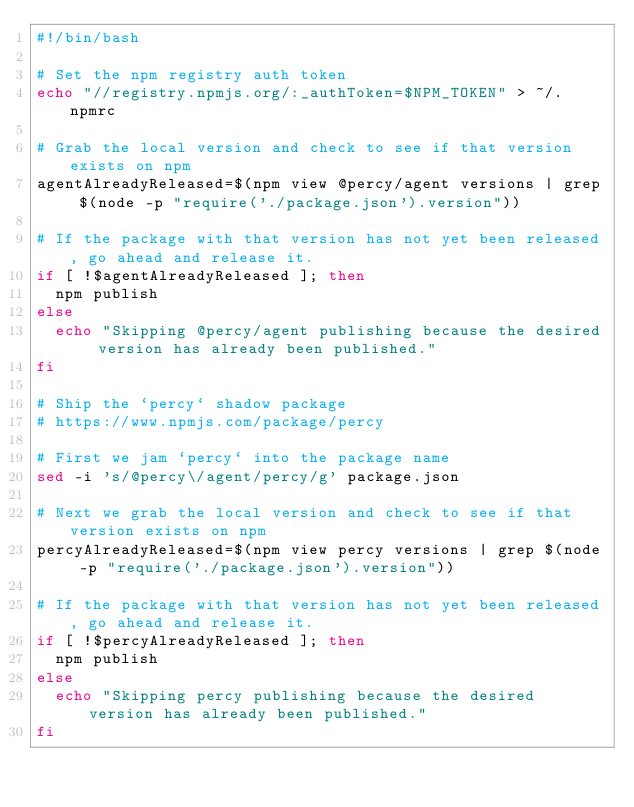Convert code to text. <code><loc_0><loc_0><loc_500><loc_500><_Bash_>#!/bin/bash

# Set the npm registry auth token
echo "//registry.npmjs.org/:_authToken=$NPM_TOKEN" > ~/.npmrc

# Grab the local version and check to see if that version exists on npm
agentAlreadyReleased=$(npm view @percy/agent versions | grep $(node -p "require('./package.json').version"))

# If the package with that version has not yet been released, go ahead and release it.
if [ !$agentAlreadyReleased ]; then
  npm publish
else
  echo "Skipping @percy/agent publishing because the desired version has already been published."
fi

# Ship the `percy` shadow package
# https://www.npmjs.com/package/percy

# First we jam `percy` into the package name
sed -i 's/@percy\/agent/percy/g' package.json

# Next we grab the local version and check to see if that version exists on npm
percyAlreadyReleased=$(npm view percy versions | grep $(node -p "require('./package.json').version"))

# If the package with that version has not yet been released, go ahead and release it.
if [ !$percyAlreadyReleased ]; then
  npm publish
else
  echo "Skipping percy publishing because the desired version has already been published."
fi
</code> 